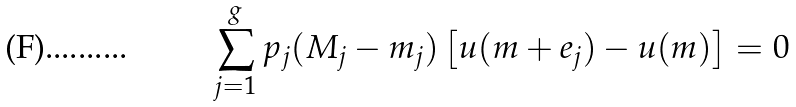<formula> <loc_0><loc_0><loc_500><loc_500>\sum _ { j = 1 } ^ { g } p _ { j } ( M _ { j } - m _ { j } ) \left [ u ( m + e _ { j } ) - u ( m ) \right ] = 0</formula> 